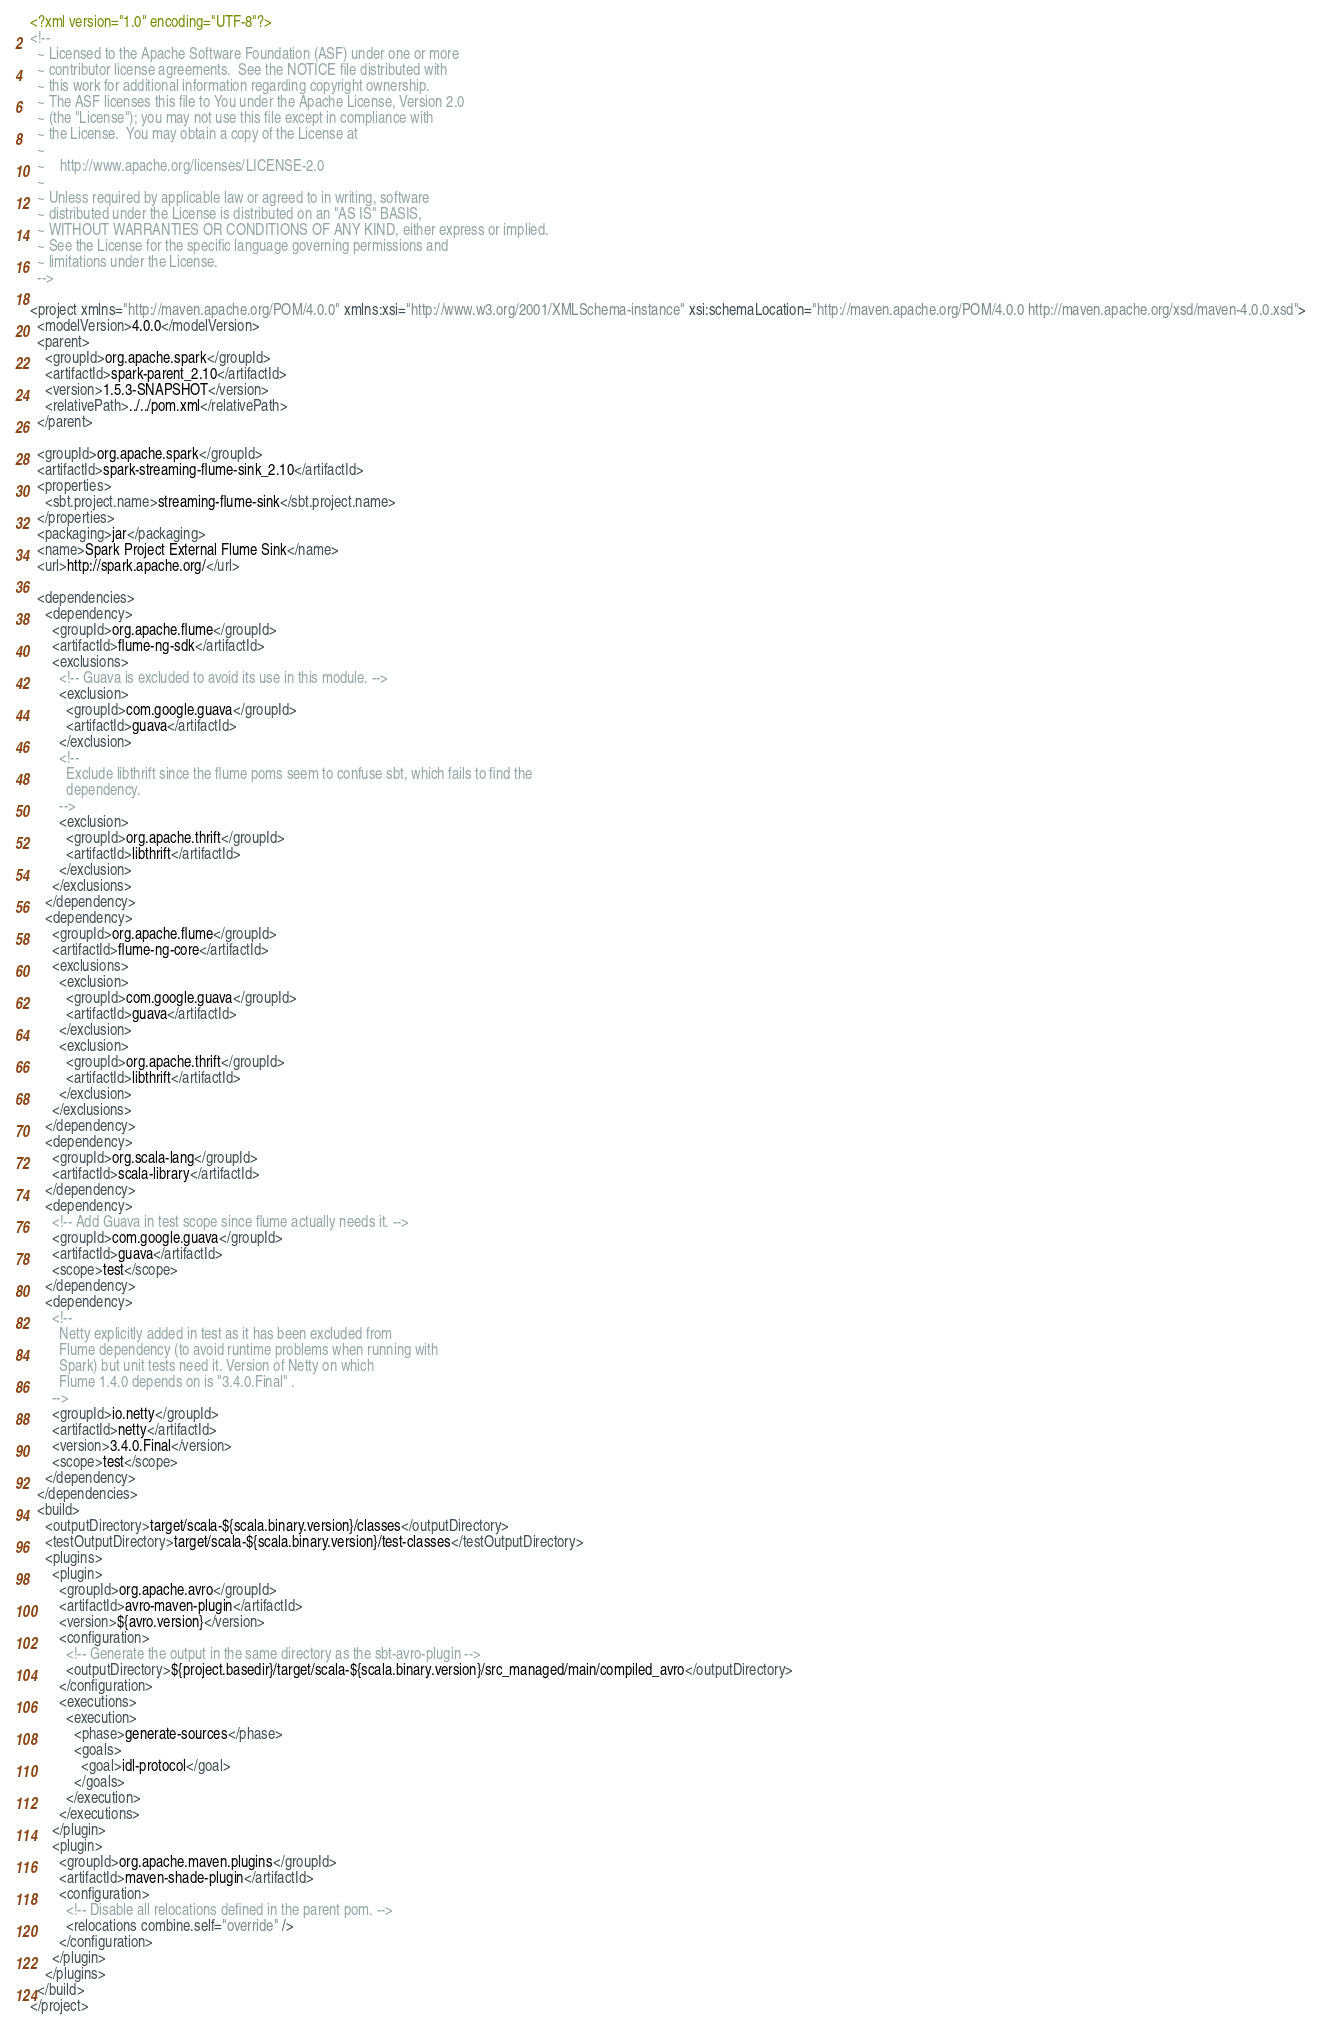<code> <loc_0><loc_0><loc_500><loc_500><_XML_><?xml version="1.0" encoding="UTF-8"?>
<!--
  ~ Licensed to the Apache Software Foundation (ASF) under one or more
  ~ contributor license agreements.  See the NOTICE file distributed with
  ~ this work for additional information regarding copyright ownership.
  ~ The ASF licenses this file to You under the Apache License, Version 2.0
  ~ (the "License"); you may not use this file except in compliance with
  ~ the License.  You may obtain a copy of the License at
  ~
  ~    http://www.apache.org/licenses/LICENSE-2.0
  ~
  ~ Unless required by applicable law or agreed to in writing, software
  ~ distributed under the License is distributed on an "AS IS" BASIS,
  ~ WITHOUT WARRANTIES OR CONDITIONS OF ANY KIND, either express or implied.
  ~ See the License for the specific language governing permissions and
  ~ limitations under the License.
  -->

<project xmlns="http://maven.apache.org/POM/4.0.0" xmlns:xsi="http://www.w3.org/2001/XMLSchema-instance" xsi:schemaLocation="http://maven.apache.org/POM/4.0.0 http://maven.apache.org/xsd/maven-4.0.0.xsd">
  <modelVersion>4.0.0</modelVersion>
  <parent>
    <groupId>org.apache.spark</groupId>
    <artifactId>spark-parent_2.10</artifactId>
    <version>1.5.3-SNAPSHOT</version>
    <relativePath>../../pom.xml</relativePath>
  </parent>

  <groupId>org.apache.spark</groupId>
  <artifactId>spark-streaming-flume-sink_2.10</artifactId>
  <properties>
    <sbt.project.name>streaming-flume-sink</sbt.project.name>
  </properties>
  <packaging>jar</packaging>
  <name>Spark Project External Flume Sink</name>
  <url>http://spark.apache.org/</url>

  <dependencies>
    <dependency>
      <groupId>org.apache.flume</groupId>
      <artifactId>flume-ng-sdk</artifactId>
      <exclusions>
        <!-- Guava is excluded to avoid its use in this module. -->
        <exclusion>
          <groupId>com.google.guava</groupId>
          <artifactId>guava</artifactId>
        </exclusion>
        <!--
          Exclude libthrift since the flume poms seem to confuse sbt, which fails to find the
          dependency.
        -->
        <exclusion>
          <groupId>org.apache.thrift</groupId>
          <artifactId>libthrift</artifactId>
        </exclusion>
      </exclusions>
    </dependency>
    <dependency>
      <groupId>org.apache.flume</groupId>
      <artifactId>flume-ng-core</artifactId>
      <exclusions>
        <exclusion>
          <groupId>com.google.guava</groupId>
          <artifactId>guava</artifactId>
        </exclusion>
        <exclusion>
          <groupId>org.apache.thrift</groupId>
          <artifactId>libthrift</artifactId>
        </exclusion>
      </exclusions>
    </dependency>
    <dependency>
      <groupId>org.scala-lang</groupId>
      <artifactId>scala-library</artifactId>
    </dependency>
    <dependency>
      <!-- Add Guava in test scope since flume actually needs it. -->
      <groupId>com.google.guava</groupId>
      <artifactId>guava</artifactId>
      <scope>test</scope>
    </dependency>
    <dependency>
      <!--
        Netty explicitly added in test as it has been excluded from
        Flume dependency (to avoid runtime problems when running with
        Spark) but unit tests need it. Version of Netty on which
        Flume 1.4.0 depends on is "3.4.0.Final" .
      -->
      <groupId>io.netty</groupId>
      <artifactId>netty</artifactId>
      <version>3.4.0.Final</version>
      <scope>test</scope>
    </dependency>
  </dependencies>
  <build>
    <outputDirectory>target/scala-${scala.binary.version}/classes</outputDirectory>
    <testOutputDirectory>target/scala-${scala.binary.version}/test-classes</testOutputDirectory>
    <plugins>
      <plugin>
        <groupId>org.apache.avro</groupId>
        <artifactId>avro-maven-plugin</artifactId>
        <version>${avro.version}</version>
        <configuration>
          <!-- Generate the output in the same directory as the sbt-avro-plugin -->
          <outputDirectory>${project.basedir}/target/scala-${scala.binary.version}/src_managed/main/compiled_avro</outputDirectory>
        </configuration>
        <executions>
          <execution>
            <phase>generate-sources</phase>
            <goals>
              <goal>idl-protocol</goal>
            </goals>
          </execution>
        </executions>
      </plugin>
      <plugin>
        <groupId>org.apache.maven.plugins</groupId>
        <artifactId>maven-shade-plugin</artifactId>
        <configuration>
          <!-- Disable all relocations defined in the parent pom. -->
          <relocations combine.self="override" />
        </configuration>
      </plugin>
    </plugins>
  </build>
</project>
</code> 